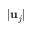<formula> <loc_0><loc_0><loc_500><loc_500>| u _ { j } |</formula> 